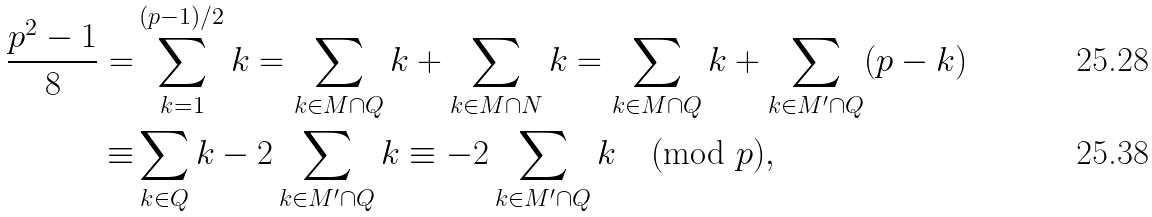<formula> <loc_0><loc_0><loc_500><loc_500>\frac { p ^ { 2 } - 1 } { 8 } = & \sum _ { k = 1 } ^ { ( p - 1 ) / 2 } k = \sum _ { k \in M \cap Q } k + \sum _ { k \in M \cap N } k = \sum _ { k \in M \cap Q } k + \sum _ { k \in M ^ { \prime } \cap Q } ( p - k ) \\ \equiv & \sum _ { k \in Q } k - 2 \sum _ { k \in M ^ { \prime } \cap Q } k \equiv - 2 \sum _ { k \in M ^ { \prime } \cap Q } k \pmod { p } ,</formula> 